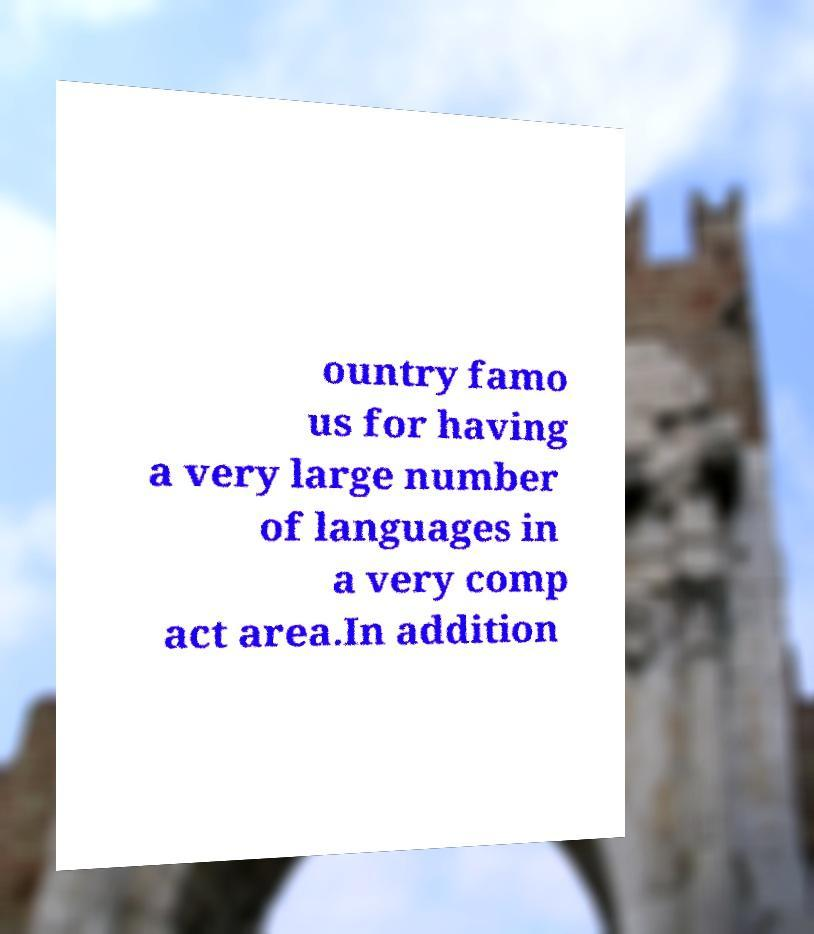Please read and relay the text visible in this image. What does it say? ountry famo us for having a very large number of languages in a very comp act area.In addition 